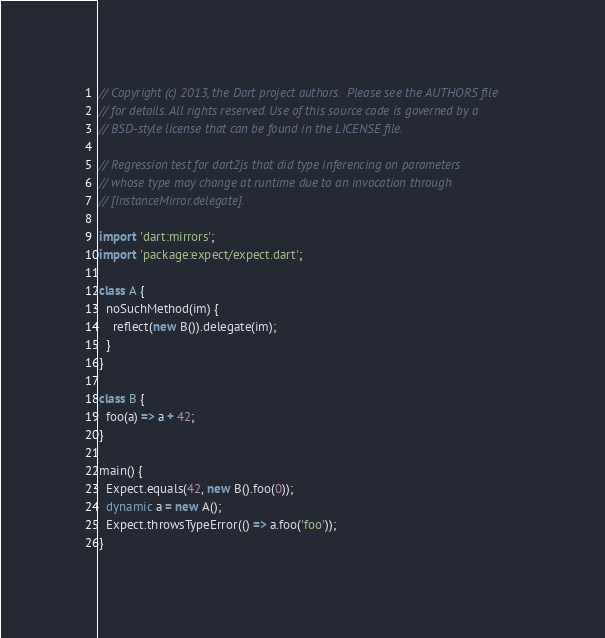Convert code to text. <code><loc_0><loc_0><loc_500><loc_500><_Dart_>// Copyright (c) 2013, the Dart project authors.  Please see the AUTHORS file
// for details. All rights reserved. Use of this source code is governed by a
// BSD-style license that can be found in the LICENSE file.

// Regression test for dart2js that did type inferencing on parameters
// whose type may change at runtime due to an invocation through
// [InstanceMirror.delegate].

import 'dart:mirrors';
import 'package:expect/expect.dart';

class A {
  noSuchMethod(im) {
    reflect(new B()).delegate(im);
  }
}

class B {
  foo(a) => a + 42;
}

main() {
  Expect.equals(42, new B().foo(0));
  dynamic a = new A();
  Expect.throwsTypeError(() => a.foo('foo'));
}
</code> 